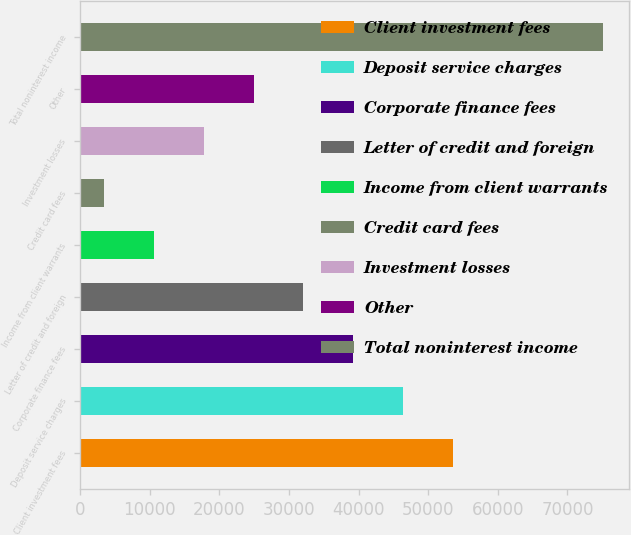Convert chart. <chart><loc_0><loc_0><loc_500><loc_500><bar_chart><fcel>Client investment fees<fcel>Deposit service charges<fcel>Corporate finance fees<fcel>Letter of credit and foreign<fcel>Income from client warrants<fcel>Credit card fees<fcel>Investment losses<fcel>Other<fcel>Total noninterest income<nl><fcel>53571.3<fcel>46408.4<fcel>39245.5<fcel>32082.6<fcel>10593.9<fcel>3431<fcel>17756.8<fcel>24919.7<fcel>75060<nl></chart> 